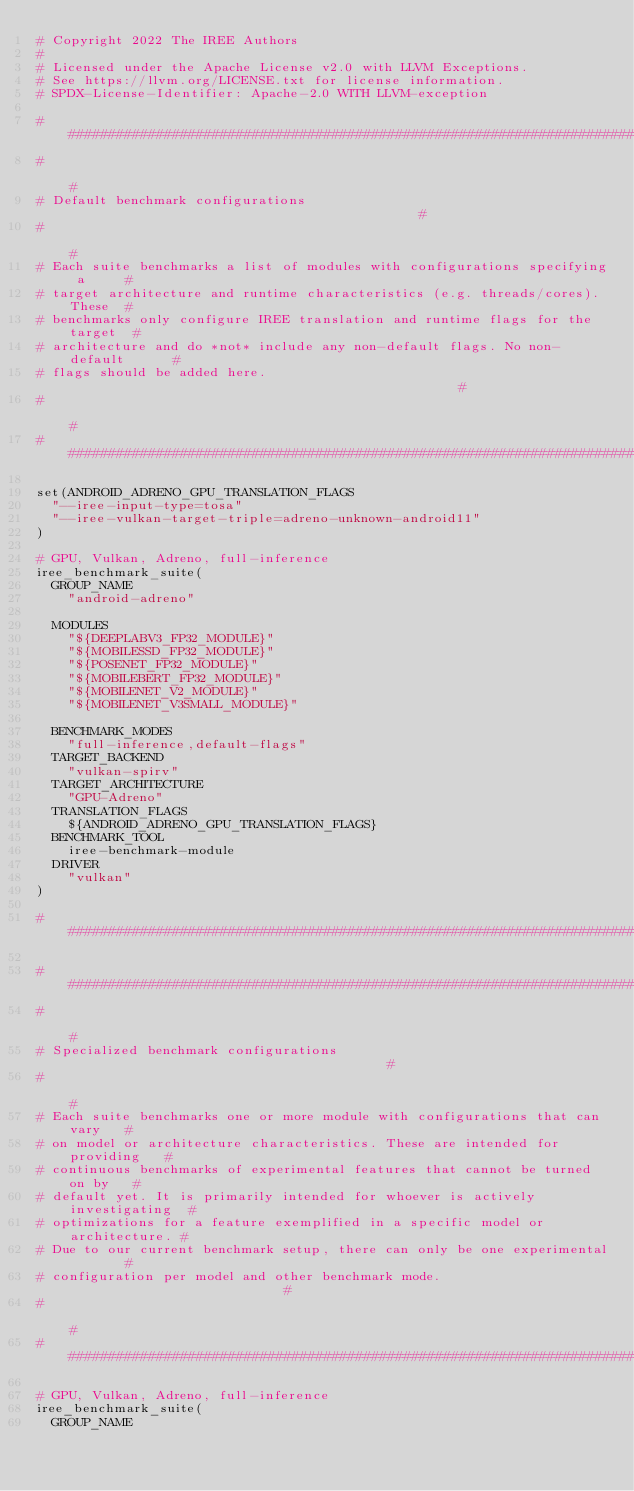<code> <loc_0><loc_0><loc_500><loc_500><_CMake_># Copyright 2022 The IREE Authors
#
# Licensed under the Apache License v2.0 with LLVM Exceptions.
# See https://llvm.org/LICENSE.txt for license information.
# SPDX-License-Identifier: Apache-2.0 WITH LLVM-exception

################################################################################
#                                                                              #
# Default benchmark configurations                                             #
#                                                                              #
# Each suite benchmarks a list of modules with configurations specifying a     #
# target architecture and runtime characteristics (e.g. threads/cores). These  #
# benchmarks only configure IREE translation and runtime flags for the target  #
# architecture and do *not* include any non-default flags. No non-default      #
# flags should be added here.                                                  #
#                                                                              #
################################################################################

set(ANDROID_ADRENO_GPU_TRANSLATION_FLAGS
  "--iree-input-type=tosa"
  "--iree-vulkan-target-triple=adreno-unknown-android11"
)

# GPU, Vulkan, Adreno, full-inference
iree_benchmark_suite(
  GROUP_NAME
    "android-adreno"

  MODULES
    "${DEEPLABV3_FP32_MODULE}"
    "${MOBILESSD_FP32_MODULE}"
    "${POSENET_FP32_MODULE}"
    "${MOBILEBERT_FP32_MODULE}"
    "${MOBILENET_V2_MODULE}"
    "${MOBILENET_V3SMALL_MODULE}"

  BENCHMARK_MODES
    "full-inference,default-flags"
  TARGET_BACKEND
    "vulkan-spirv"
  TARGET_ARCHITECTURE
    "GPU-Adreno"
  TRANSLATION_FLAGS
    ${ANDROID_ADRENO_GPU_TRANSLATION_FLAGS}
  BENCHMARK_TOOL
    iree-benchmark-module
  DRIVER
    "vulkan"
)

################################################################################

################################################################################
#                                                                              #
# Specialized benchmark configurations                                         #
#                                                                              #
# Each suite benchmarks one or more module with configurations that can vary   #
# on model or architecture characteristics. These are intended for providing   #
# continuous benchmarks of experimental features that cannot be turned on by   #
# default yet. It is primarily intended for whoever is actively investigating  #
# optimizations for a feature exemplified in a specific model or architecture. #
# Due to our current benchmark setup, there can only be one experimental       #
# configuration per model and other benchmark mode.                            #
#                                                                              #
################################################################################

# GPU, Vulkan, Adreno, full-inference
iree_benchmark_suite(
  GROUP_NAME</code> 